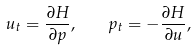<formula> <loc_0><loc_0><loc_500><loc_500>u _ { t } = \frac { \partial H } { \partial p } , \quad p _ { t } = - \frac { \partial H } { \partial u } ,</formula> 